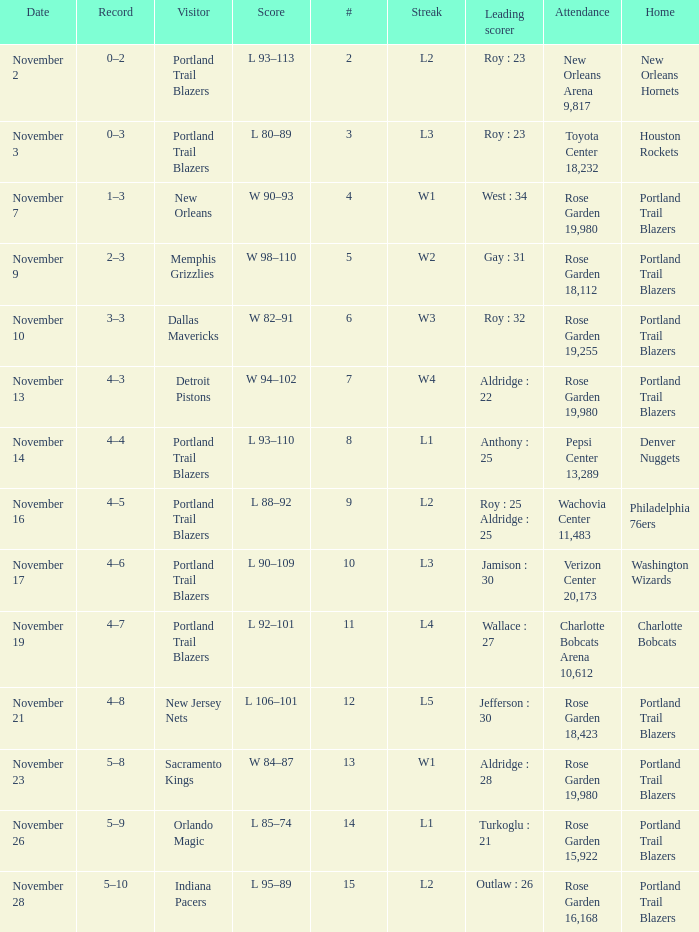 what's the score where record is 0–2 L 93–113. 